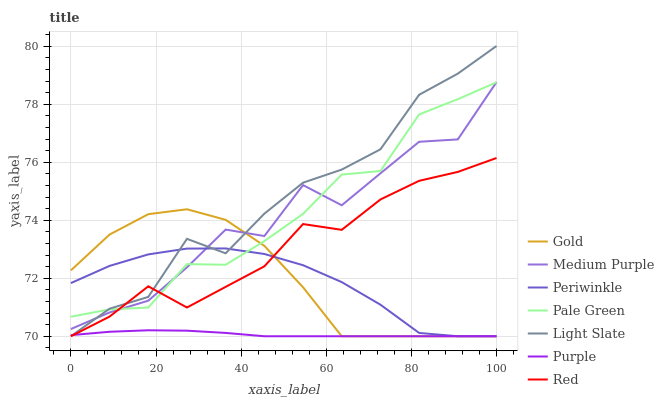Does Purple have the minimum area under the curve?
Answer yes or no. Yes. Does Light Slate have the maximum area under the curve?
Answer yes or no. Yes. Does Medium Purple have the minimum area under the curve?
Answer yes or no. No. Does Medium Purple have the maximum area under the curve?
Answer yes or no. No. Is Purple the smoothest?
Answer yes or no. Yes. Is Medium Purple the roughest?
Answer yes or no. Yes. Is Light Slate the smoothest?
Answer yes or no. No. Is Light Slate the roughest?
Answer yes or no. No. Does Gold have the lowest value?
Answer yes or no. Yes. Does Medium Purple have the lowest value?
Answer yes or no. No. Does Light Slate have the highest value?
Answer yes or no. Yes. Does Medium Purple have the highest value?
Answer yes or no. No. Is Purple less than Pale Green?
Answer yes or no. Yes. Is Pale Green greater than Purple?
Answer yes or no. Yes. Does Red intersect Purple?
Answer yes or no. Yes. Is Red less than Purple?
Answer yes or no. No. Is Red greater than Purple?
Answer yes or no. No. Does Purple intersect Pale Green?
Answer yes or no. No. 